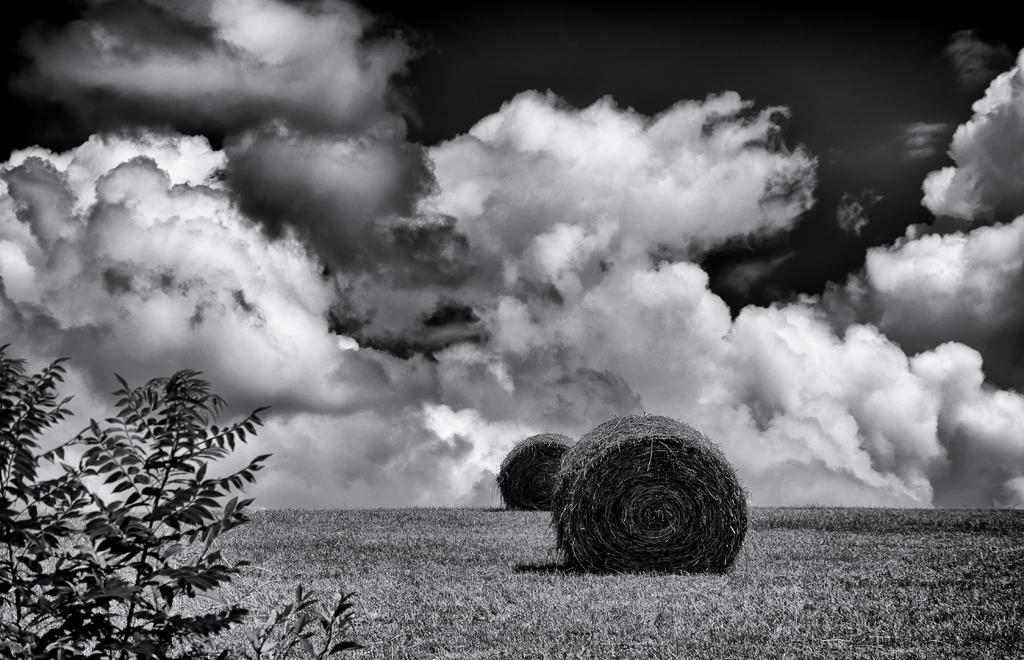What type of vegetation can be seen on the left side of the image? There are leaves on the left side of the image. What is located in the center of the image? There are objects in the center of the image. How would you describe the sky in the image? The sky is cloudy in the image. How many boys are playing with plastic rocks in the image? There are no boys or rocks present in the image. What type of plastic material can be seen in the image? There is no plastic material visible in the image. 